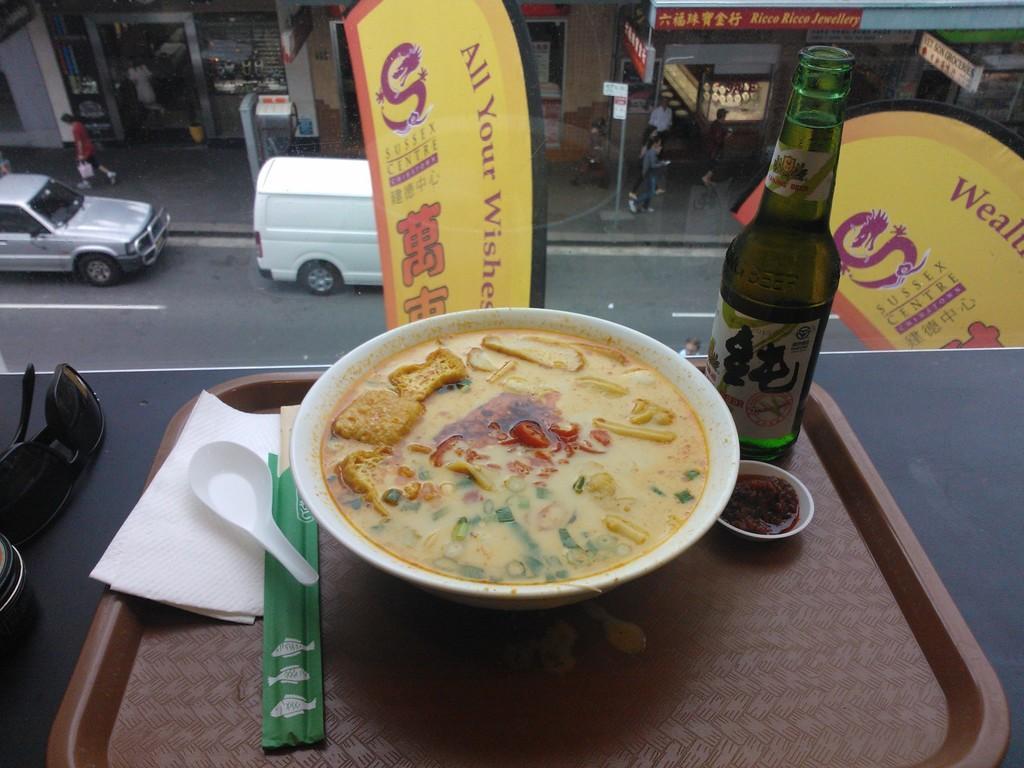How would you summarize this image in a sentence or two? In this image there is a food in white color bowl is kept in a tray at bottom of this image. There is a white color spoon and tissue kept at left side of this image. There is one goggles kept at left side of this image and there are some vehicles is in middle of this image. there are some shops at top of this image. There is one bottle kept in a tray at right side of this image. 